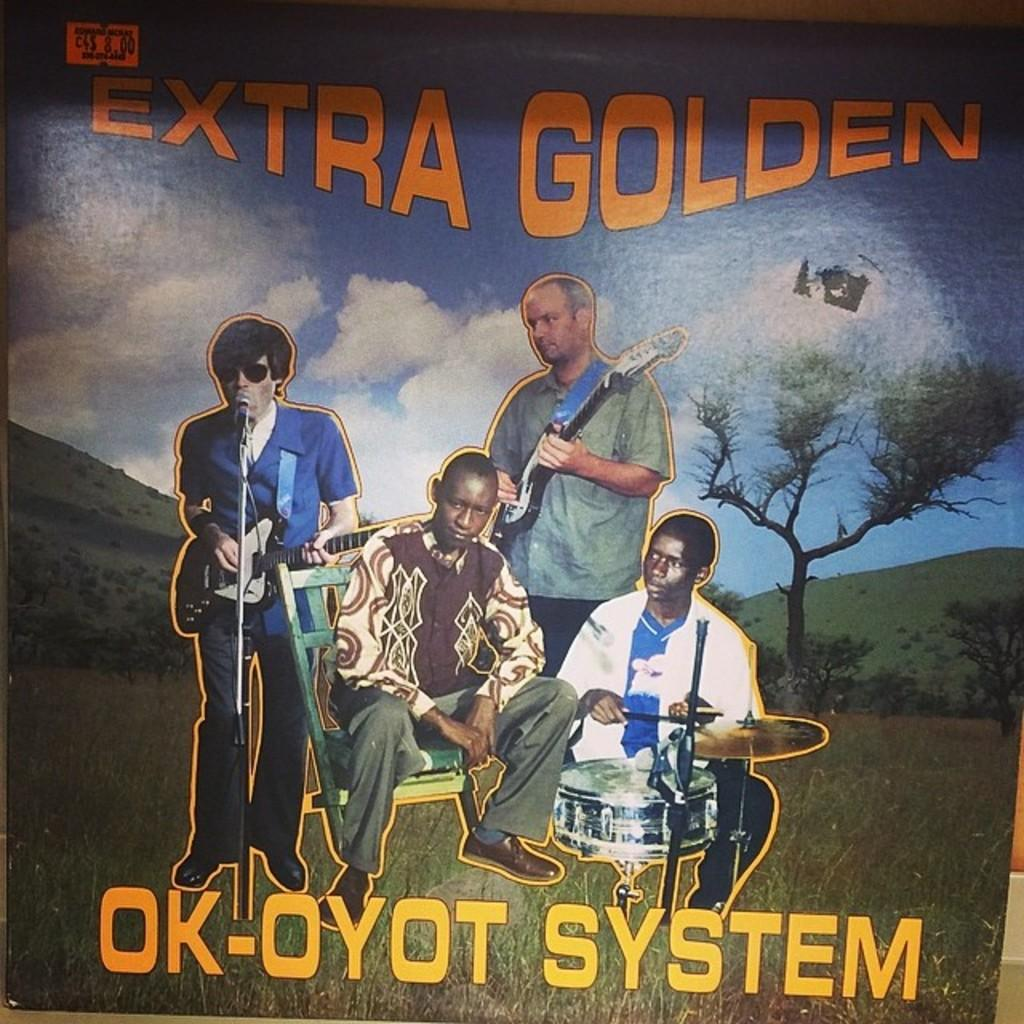Provide a one-sentence caption for the provided image. A record or cd cover called Extra Golden is showed with a picture of the band Ok-Oyot System on it. 